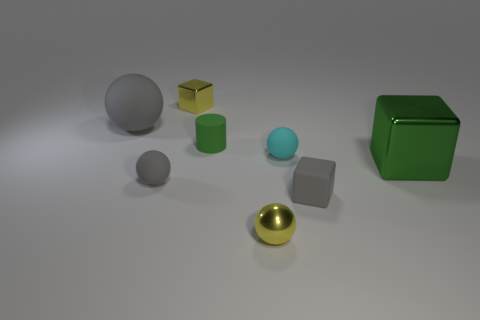Subtract all small yellow metallic balls. How many balls are left? 3 Subtract all purple blocks. How many gray spheres are left? 2 Subtract all cyan spheres. How many spheres are left? 3 Subtract 1 cubes. How many cubes are left? 2 Add 2 rubber blocks. How many objects exist? 10 Subtract all blocks. How many objects are left? 5 Subtract all big yellow rubber objects. Subtract all cylinders. How many objects are left? 7 Add 4 small green objects. How many small green objects are left? 5 Add 1 tiny green cylinders. How many tiny green cylinders exist? 2 Subtract 0 red cubes. How many objects are left? 8 